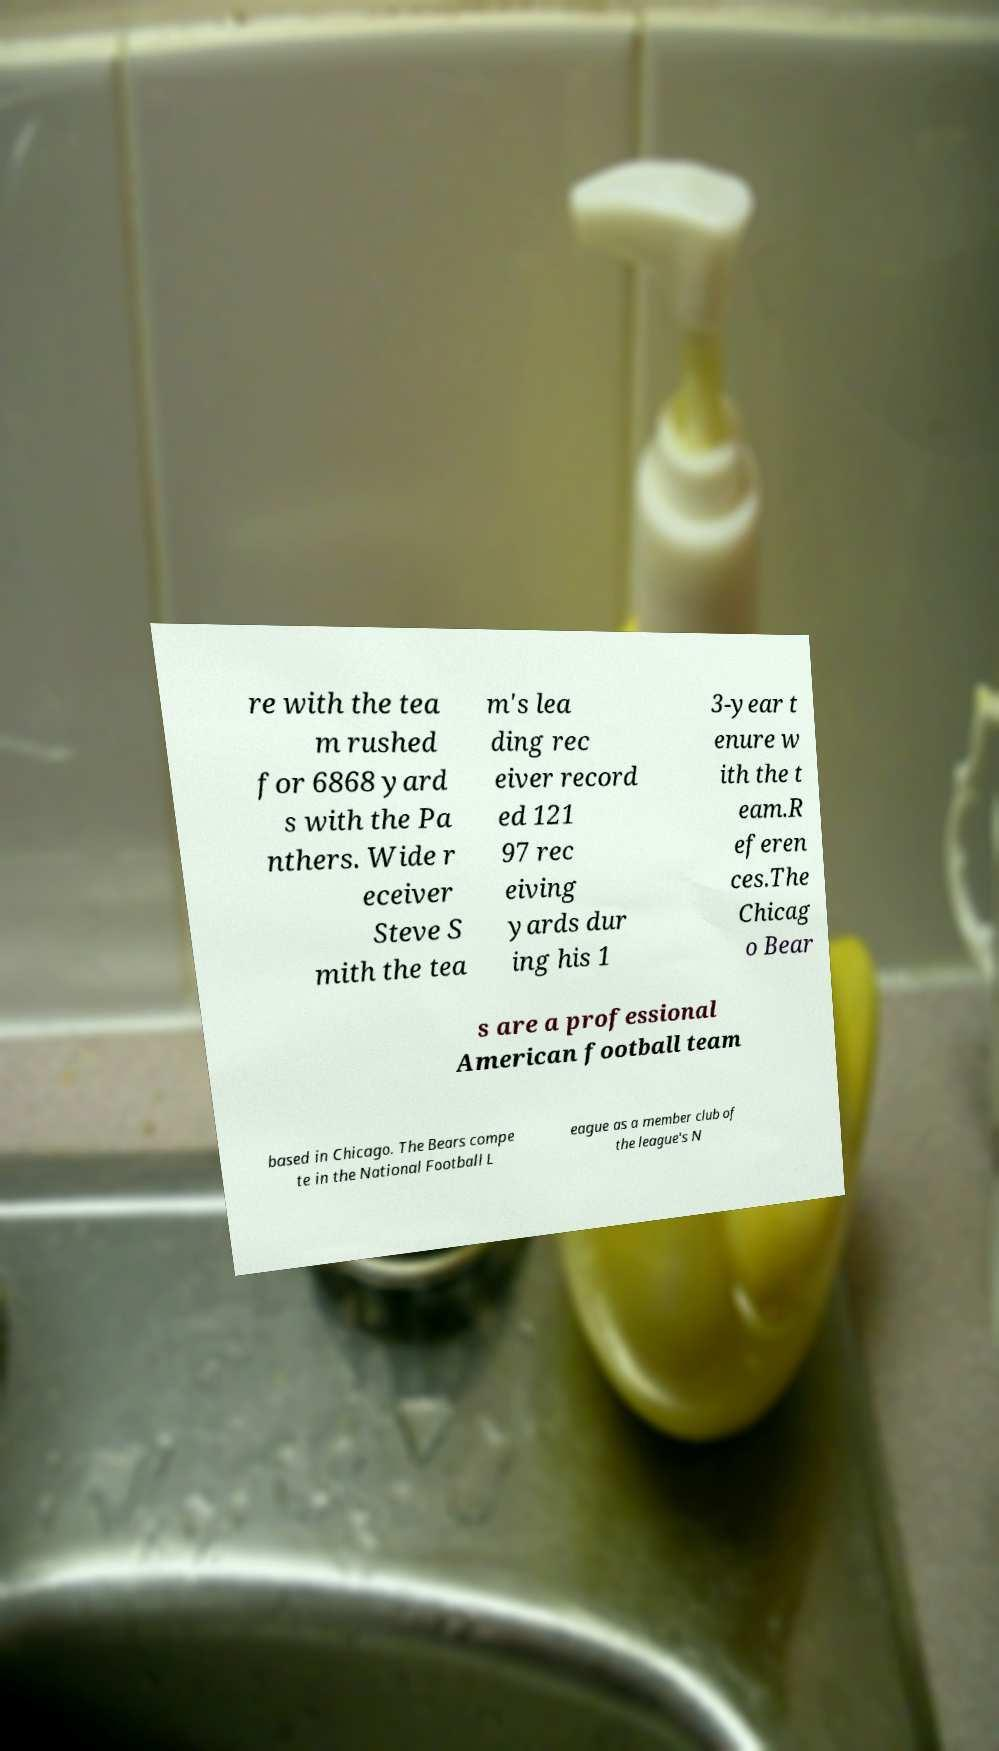What messages or text are displayed in this image? I need them in a readable, typed format. re with the tea m rushed for 6868 yard s with the Pa nthers. Wide r eceiver Steve S mith the tea m's lea ding rec eiver record ed 121 97 rec eiving yards dur ing his 1 3-year t enure w ith the t eam.R eferen ces.The Chicag o Bear s are a professional American football team based in Chicago. The Bears compe te in the National Football L eague as a member club of the league's N 